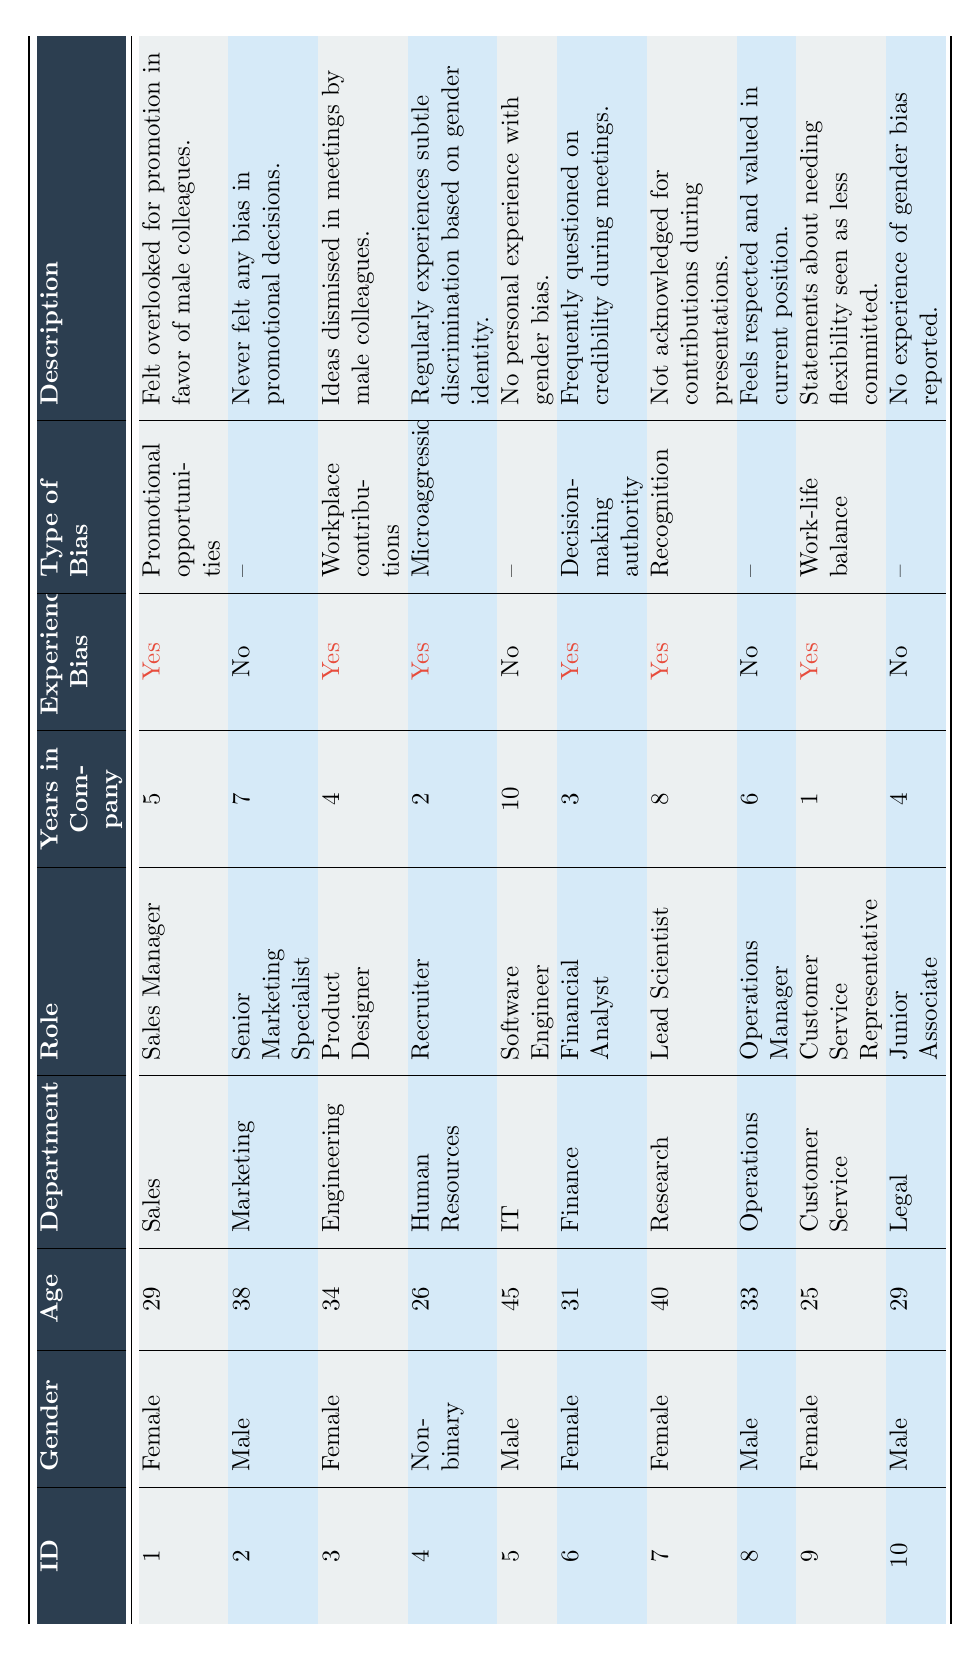What is the total number of respondents who experienced bias? Looking through the "Experienced Bias" column, we can count the number of "Yes" entries, which are associated with respondents 1, 3, 4, 6, 7, and 9. This gives us a total of 6 respondents.
Answer: 6 How many males reported experiencing bias? By examining the gender column and focusing on those who reported "Yes" in the "Experienced Bias" column, we find only respondent 7 is female while there are no males among those who experienced bias.
Answer: 0 What percentage of females experienced bias? There are 5 female respondents (1, 3, 6, 7, and 9). Out of these, 4 experienced bias (1, 3, 6, 7, and 9). To find the percentage, we calculate (4/5) * 100, which equals 80%.
Answer: 80% What bias type did respondent 4 experience? Looking at respondent 4's entry, we can see that they experienced "Microaggressions" as the type of bias in the table.
Answer: Microaggressions Are there any Non-binary respondents who reported not experiencing bias? By checking the rows in the table, we find that there is one Non-binary respondent (respondent 4) and they did report experiencing bias. Therefore, the answer is no.
Answer: No What is the average age of respondents who experienced bias? The ages of respondents who experienced bias are 29, 34, 26, 31, 40, and 25. Summing these gives us 29 + 34 + 26 + 31 + 40 + 25 = 185. There are 6 respondents, so we calculate the average as 185/6, which equals approximately 30.83.
Answer: 30.83 What role has the highest seniority among respondents who experienced bias? From the table, roles of respondents who reported bias are Sales Manager, Product Designer, Recruiter, Financial Analyst, Lead Scientist, and Customer Service Representative. Among these, the Lead Scientist has the highest level of seniority.
Answer: Lead Scientist Which department has the most respondents reporting bias? By reviewing the departments of the respondents who experienced bias, we see that Sales, Engineering, Human Resources, Finance, Research, and Customer Service are represented. Each department has only one respondent, indicating there is a tie between departments regarding reported bias.
Answer: Tie between departments How many years in the company does the respondent with the longest experience, who reported bias, have? Looking through the "Years in Company" for those who experienced bias, we find respondent 5 has 10 years, while the highest among those with bias (the longest) has 8 years. Thus, the answer is 8 years.
Answer: 8 What are the age groups of respondents who did not experience bias? The ages of respondents that did not experience bias are 38, 45, 33, and 29. This indicates that the age groups are: 30-39 (38), 40-49 (45), 30-39 (33), and 20-29 (29).
Answer: 20-29, 30-39, and 40-49 Are there more respondents in the Sales department or the IT department who reported bias? Upon checking, only the Sales department has a respondent (1) who experienced bias, while the IT department has a respondent (5) who did not report bias, thus Sales has more respondents reporting bias.
Answer: Sales department has more 